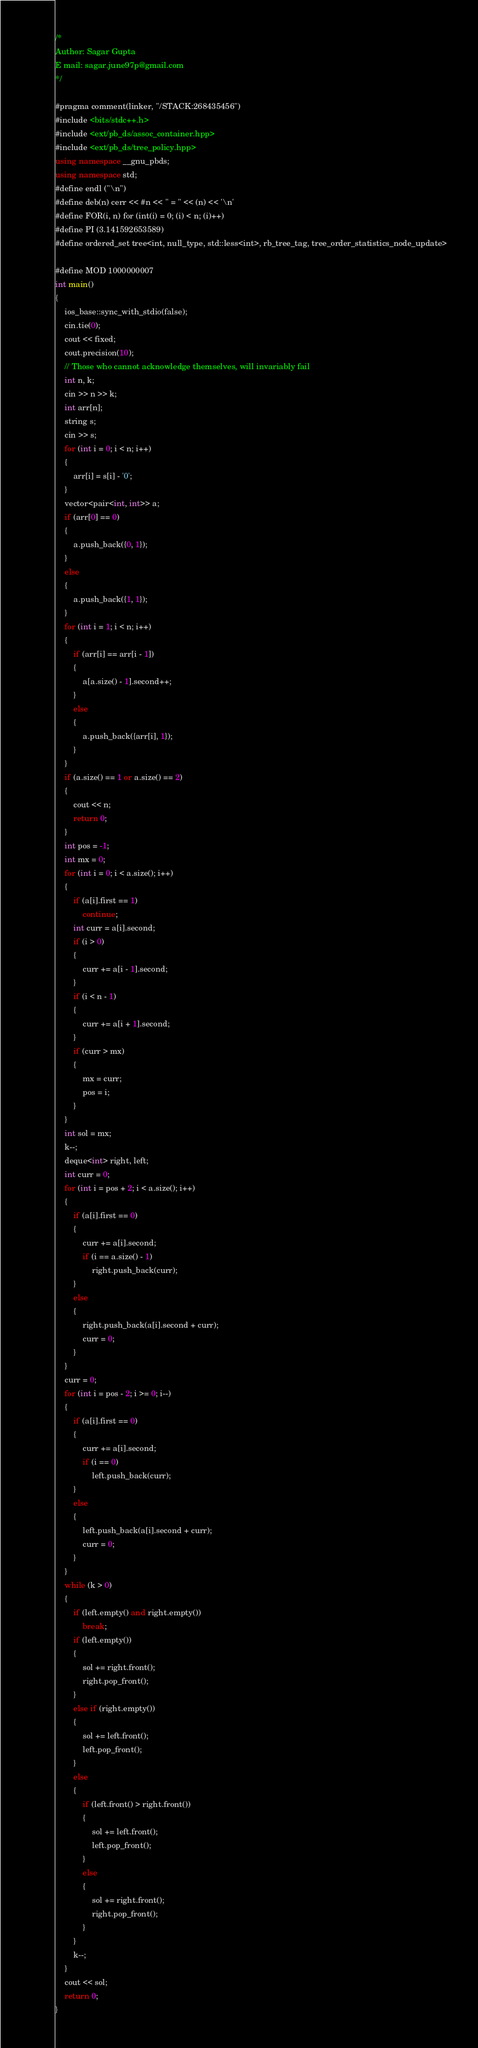<code> <loc_0><loc_0><loc_500><loc_500><_C++_>/*
Author: Sagar Gupta
E mail: sagar.june97p@gmail.com
*/

#pragma comment(linker, "/STACK:268435456")
#include <bits/stdc++.h>
#include <ext/pb_ds/assoc_container.hpp>
#include <ext/pb_ds/tree_policy.hpp>
using namespace __gnu_pbds;
using namespace std;
#define endl ("\n")
#define deb(n) cerr << #n << " = " << (n) << '\n'
#define FOR(i, n) for (int(i) = 0; (i) < n; (i)++)
#define PI (3.141592653589)
#define ordered_set tree<int, null_type, std::less<int>, rb_tree_tag, tree_order_statistics_node_update>

#define MOD 1000000007
int main()
{
    ios_base::sync_with_stdio(false);
    cin.tie(0);
    cout << fixed;
    cout.precision(10);
    // Those who cannot acknowledge themselves, will invariably fail
    int n, k;
    cin >> n >> k;
    int arr[n];
    string s;
    cin >> s;
    for (int i = 0; i < n; i++)
    {
        arr[i] = s[i] - '0';
    }
    vector<pair<int, int>> a;
    if (arr[0] == 0)
    {
        a.push_back({0, 1});
    }
    else
    {
        a.push_back({1, 1});
    }
    for (int i = 1; i < n; i++)
    {
        if (arr[i] == arr[i - 1])
        {
            a[a.size() - 1].second++;
        }
        else
        {
            a.push_back({arr[i], 1});
        }
    }
    if (a.size() == 1 or a.size() == 2)
    {
        cout << n;
        return 0;
    }
    int pos = -1;
    int mx = 0;
    for (int i = 0; i < a.size(); i++)
    {
        if (a[i].first == 1)
            continue;
        int curr = a[i].second;
        if (i > 0)
        {
            curr += a[i - 1].second;
        }
        if (i < n - 1)
        {
            curr += a[i + 1].second;
        }
        if (curr > mx)
        {
            mx = curr;
            pos = i;
        }
    }
    int sol = mx;
    k--;
    deque<int> right, left;
    int curr = 0;
    for (int i = pos + 2; i < a.size(); i++)
    {
        if (a[i].first == 0)
        {
            curr += a[i].second;
            if (i == a.size() - 1)
                right.push_back(curr);
        }
        else
        {
            right.push_back(a[i].second + curr);
            curr = 0;
        }
    }
    curr = 0;
    for (int i = pos - 2; i >= 0; i--)
    {
        if (a[i].first == 0)
        {
            curr += a[i].second;
            if (i == 0)
                left.push_back(curr);
        }
        else
        {
            left.push_back(a[i].second + curr);
            curr = 0;
        }
    }
    while (k > 0)
    {
        if (left.empty() and right.empty())
            break;
        if (left.empty())
        {
            sol += right.front();
            right.pop_front();
        }
        else if (right.empty())
        {
            sol += left.front();
            left.pop_front();
        }
        else
        {
            if (left.front() > right.front())
            {
                sol += left.front();
                left.pop_front();
            }
            else
            {
                sol += right.front();
                right.pop_front();
            }
        }
        k--;
    }
    cout << sol;
    return 0;
}</code> 